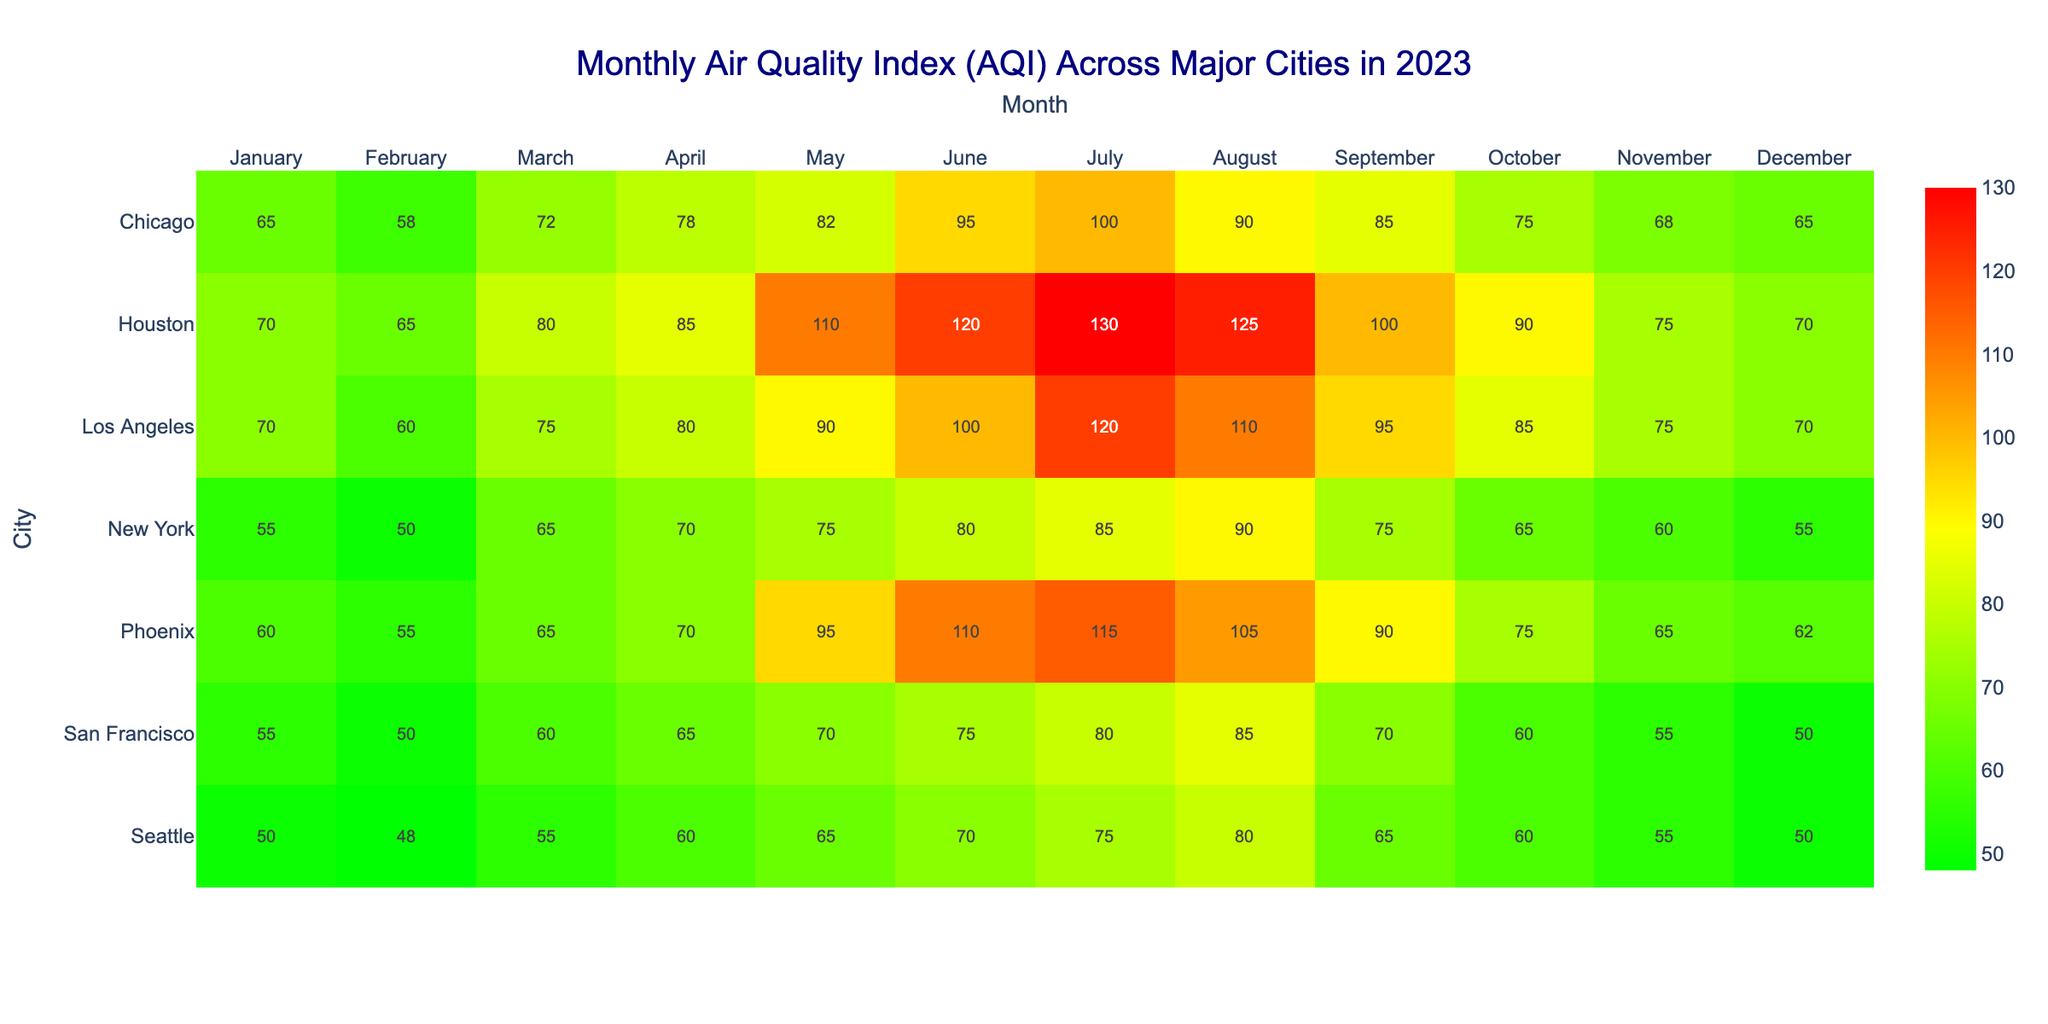What is the Air Quality Index (AQI) for Los Angeles in July? The table shows that for Los Angeles in July, the AQI reading is 120. This value is directly located in the corresponding cell for Los Angeles and July.
Answer: 120 Which city has the highest AQI reading in June? By reviewing the June column, I can see that Houston has the highest AQI reading at 120, while Los Angeles, Chicago, and Phoenix have lower values of 100, 95, and 110 respectively.
Answer: Houston In which month did New York exhibit an "Unhealthy for Sensitive Groups" AQI reading? Looking at the New York row, I find that the AQI reading is categorized as "Unhealthy for Sensitive Groups" in August, which is the only instance for New York across the months listed.
Answer: August What is the average AQI for Seattle over the year? To find the average, I first sum up the AQI values for each month: (50 + 48 + 55 + 60 + 65 + 70 + 75 + 80 + 65 + 60 + 55 + 50) =  780. There are 12 months, so the average is 780 / 12 = 65.
Answer: 65 Is the AQI category for Chicago in December classified as "Good"? In the table, the AQI for Chicago in December reads 65, and it is labeled as "Moderate," not "Good." Therefore, the answer is no.
Answer: No What is the difference in AQI between June and July for Houston? For Houston, the AQI in June is 120 and in July is 130. The difference is calculated as 130 - 120 = 10, indicating an increase.
Answer: 10 Which city consistently scored "Good" AQI in January throughout the year? By scanning through the January readings, both Seattle and San Francisco show AQI readings of 50 and 55 respectively, both classified as "Good." Other cities do not maintain this status.
Answer: Seattle and San Francisco Was there any month where Chicago had an "Unhealthy" AQI? The table reveals that in July, Chicago's AQI was 100 and categorized as "Unhealthy." It confirms that there was such a month.
Answer: Yes 